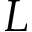<formula> <loc_0><loc_0><loc_500><loc_500>L</formula> 